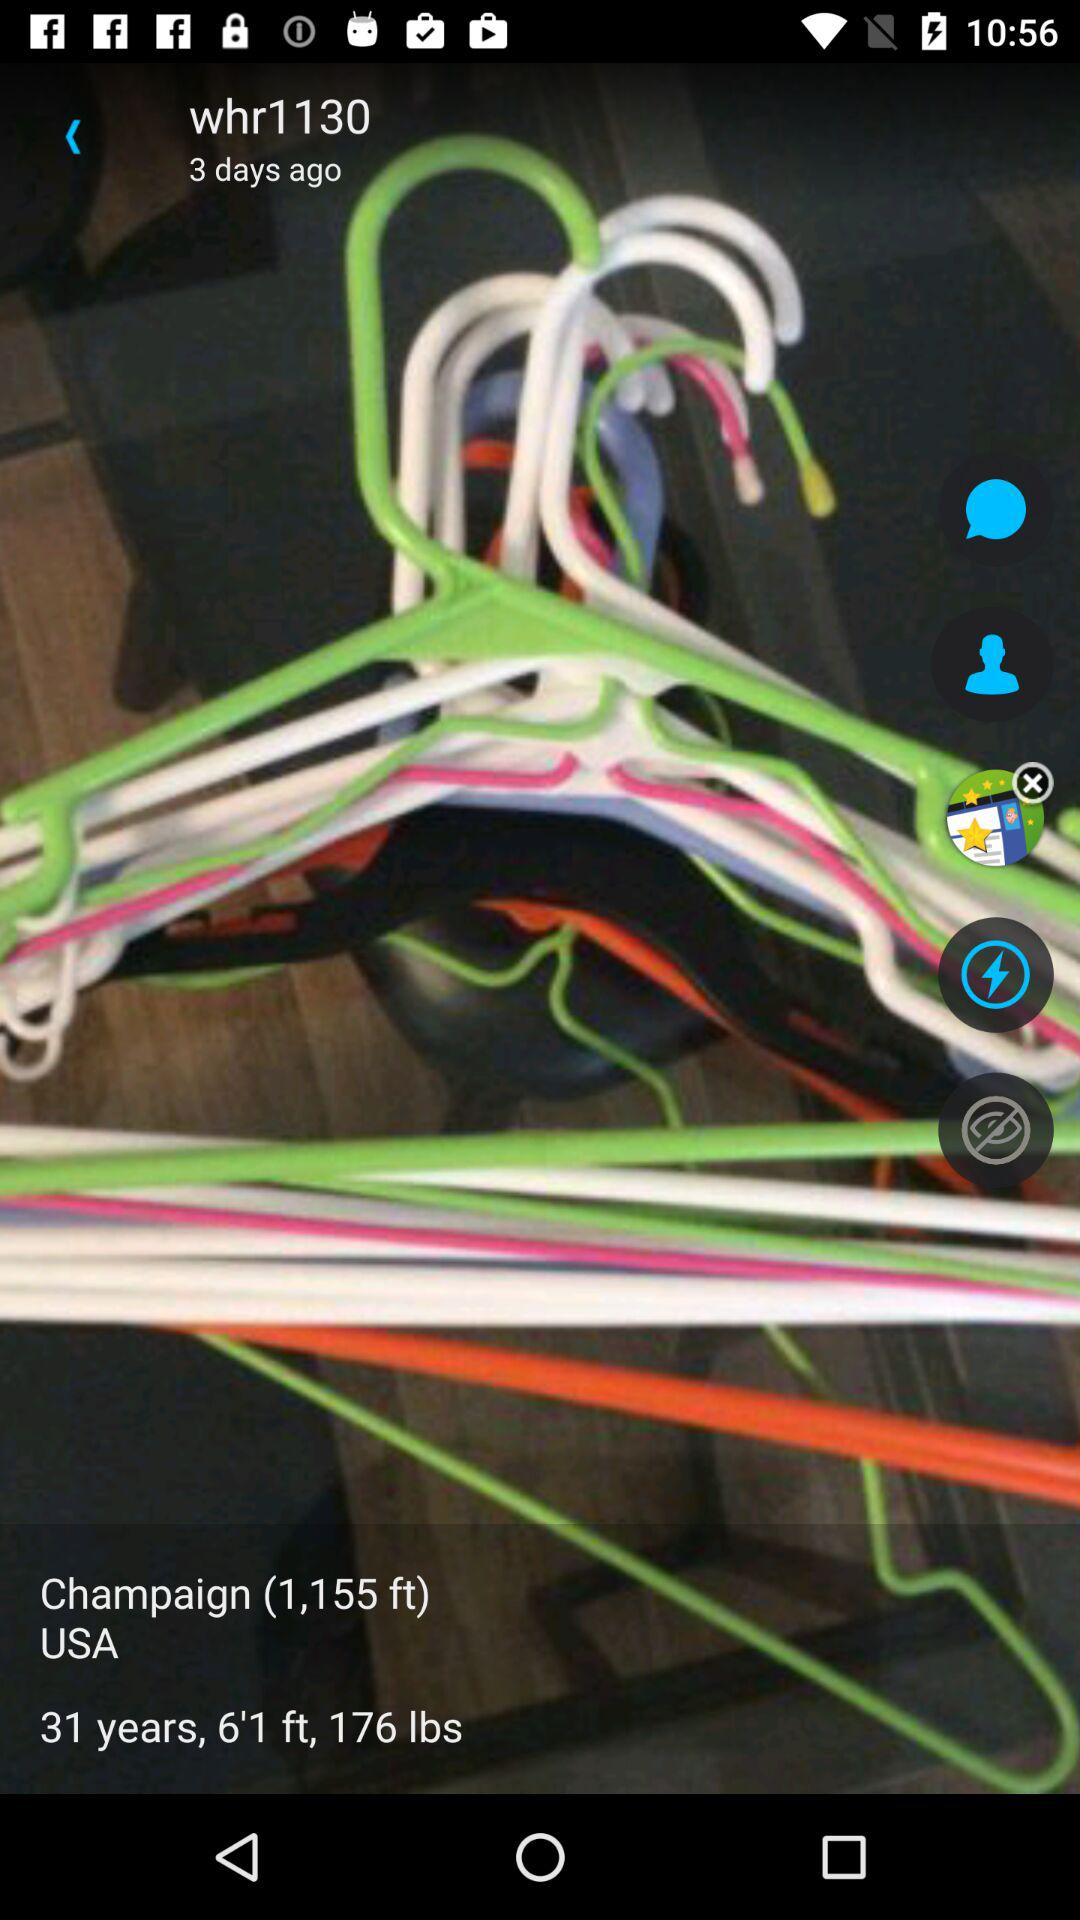What is the age? The age is 31 years. 